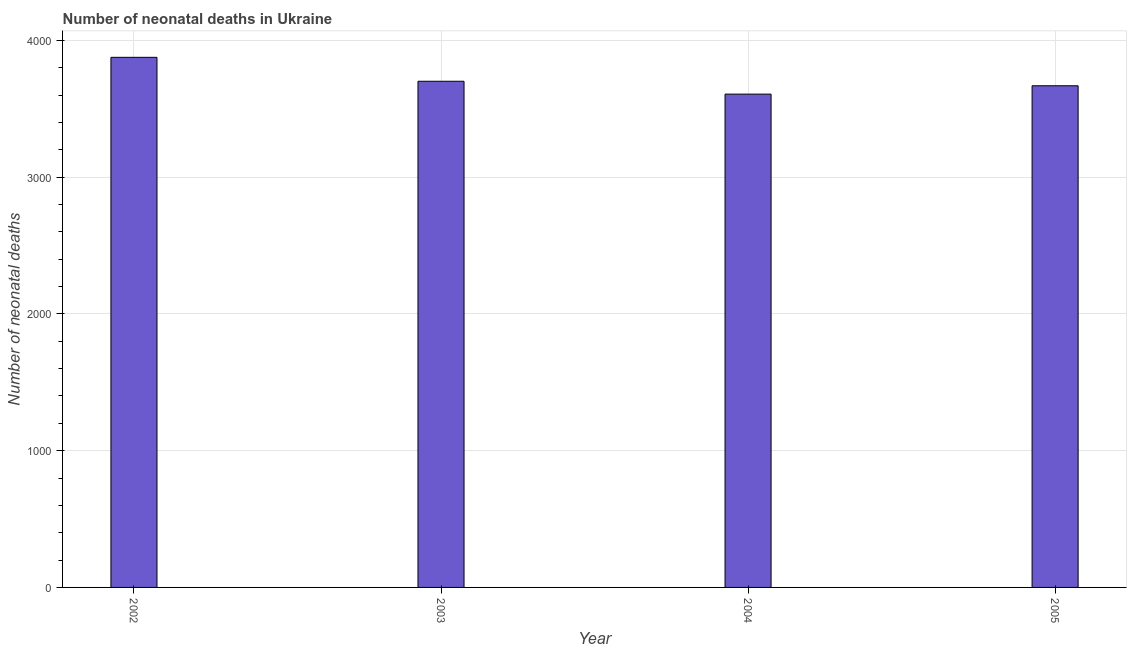Does the graph contain grids?
Provide a short and direct response. Yes. What is the title of the graph?
Your response must be concise. Number of neonatal deaths in Ukraine. What is the label or title of the X-axis?
Offer a terse response. Year. What is the label or title of the Y-axis?
Offer a terse response. Number of neonatal deaths. What is the number of neonatal deaths in 2002?
Provide a short and direct response. 3876. Across all years, what is the maximum number of neonatal deaths?
Your answer should be very brief. 3876. Across all years, what is the minimum number of neonatal deaths?
Your answer should be very brief. 3607. In which year was the number of neonatal deaths minimum?
Your answer should be very brief. 2004. What is the sum of the number of neonatal deaths?
Give a very brief answer. 1.49e+04. What is the difference between the number of neonatal deaths in 2004 and 2005?
Provide a succinct answer. -61. What is the average number of neonatal deaths per year?
Keep it short and to the point. 3713. What is the median number of neonatal deaths?
Your answer should be compact. 3684.5. What is the difference between the highest and the second highest number of neonatal deaths?
Provide a succinct answer. 175. What is the difference between the highest and the lowest number of neonatal deaths?
Your answer should be very brief. 269. How many bars are there?
Provide a short and direct response. 4. What is the difference between two consecutive major ticks on the Y-axis?
Provide a succinct answer. 1000. What is the Number of neonatal deaths of 2002?
Provide a short and direct response. 3876. What is the Number of neonatal deaths of 2003?
Your answer should be very brief. 3701. What is the Number of neonatal deaths in 2004?
Give a very brief answer. 3607. What is the Number of neonatal deaths in 2005?
Ensure brevity in your answer.  3668. What is the difference between the Number of neonatal deaths in 2002 and 2003?
Give a very brief answer. 175. What is the difference between the Number of neonatal deaths in 2002 and 2004?
Keep it short and to the point. 269. What is the difference between the Number of neonatal deaths in 2002 and 2005?
Offer a terse response. 208. What is the difference between the Number of neonatal deaths in 2003 and 2004?
Your response must be concise. 94. What is the difference between the Number of neonatal deaths in 2003 and 2005?
Ensure brevity in your answer.  33. What is the difference between the Number of neonatal deaths in 2004 and 2005?
Your response must be concise. -61. What is the ratio of the Number of neonatal deaths in 2002 to that in 2003?
Your answer should be very brief. 1.05. What is the ratio of the Number of neonatal deaths in 2002 to that in 2004?
Your answer should be compact. 1.07. What is the ratio of the Number of neonatal deaths in 2002 to that in 2005?
Your response must be concise. 1.06. What is the ratio of the Number of neonatal deaths in 2003 to that in 2004?
Ensure brevity in your answer.  1.03. What is the ratio of the Number of neonatal deaths in 2003 to that in 2005?
Give a very brief answer. 1.01. 